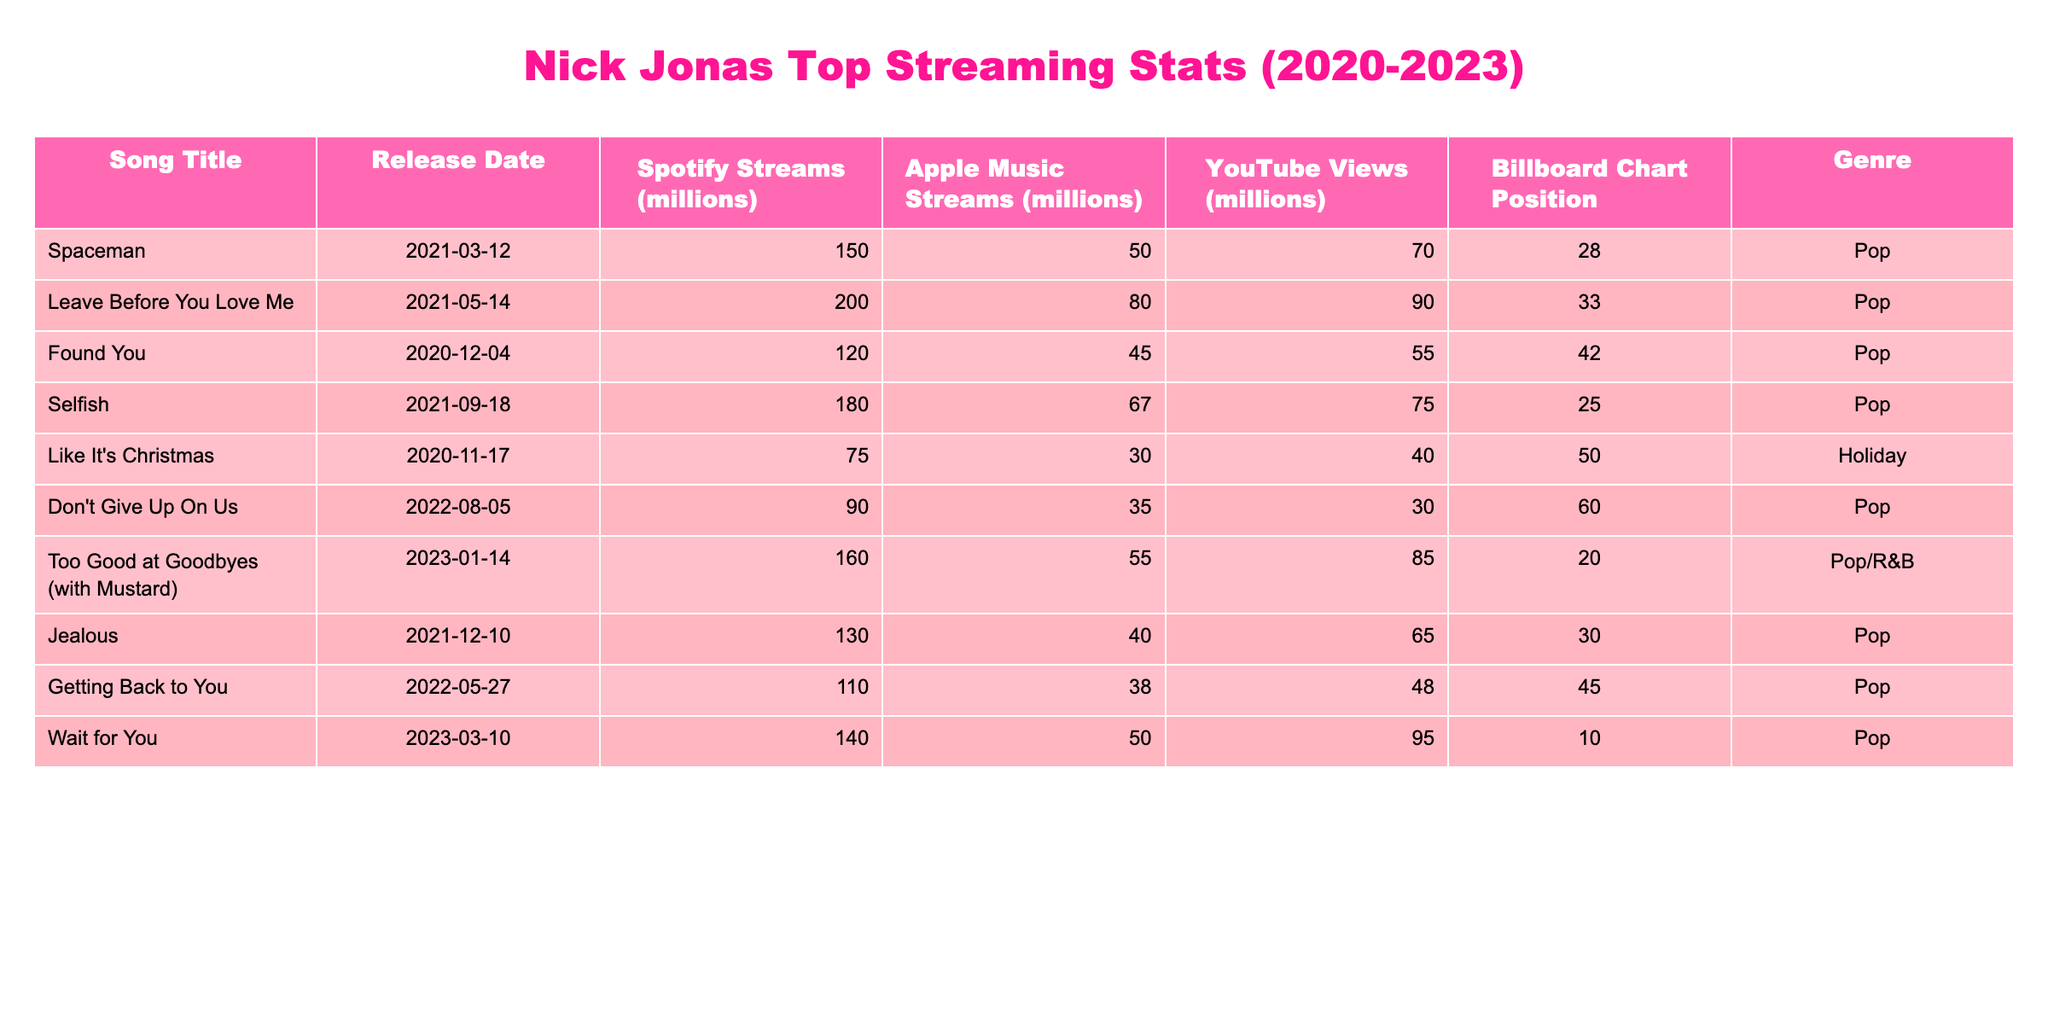What is the highest number of Spotify streams for a Nick Jonas song in the table? The highest number of Spotify streams is 200 million for the song "Leave Before You Love Me."
Answer: 200 million What is the total number of Apple Music streams for all the songs combined? Adding the Apple Music streams for all songs: 50 + 80 + 45 + 67 + 30 + 35 + 55 + 40 + 38 + 50 =  440 million.
Answer: 440 million Which Nick Jonas song has the most YouTube views? The song with the most YouTube views is "Leave Before You Love Me" with 90 million views.
Answer: 90 million Is "Too Good at Goodbyes (with Mustard)" the only song released in 2023? Yes, based on the release dates, it is the only song released in 2023.
Answer: Yes What position did "Wait for You" reach on the Billboard chart? "Wait for You" reached position 10 on the Billboard chart.
Answer: 10 Which song has the least number of Spotify streams? The song with the least Spotify streams is "Like It's Christmas" with 75 million streams.
Answer: 75 million What is the average number of YouTube views for all the songs? First, add the YouTube views: 70 + 90 + 55 + 75 + 40 + 30 + 85 + 65 + 48 + 95 =  678 million. Then divide by the 10 songs to find the average: 678 / 10 = 67.8 million views.
Answer: 67.8 million What are the genres of the songs that charted in the top 30? The songs charting in the top 30, "Selfish," "Too Good at Goodbyes (with Mustard)," and "Wait for You" are all Pop, while "Leave Before You Love Me" is also Pop.
Answer: Pop Which song has the highest Billboard chart position, and what is that position? "Wait for You" has the highest Billboard position at #10.
Answer: 10 How many more Apple Music streams does "Selfish" have compared to "Found You"? "Selfish" has 67 million Apple Music streams and "Found You" has 45 million. The difference is 67 - 45 = 22 million streams.
Answer: 22 million 